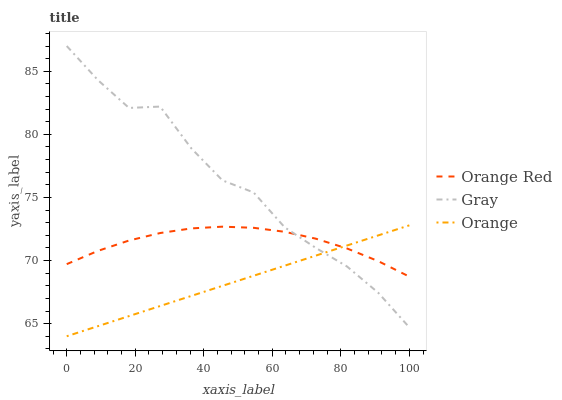Does Orange have the minimum area under the curve?
Answer yes or no. Yes. Does Gray have the maximum area under the curve?
Answer yes or no. Yes. Does Orange Red have the minimum area under the curve?
Answer yes or no. No. Does Orange Red have the maximum area under the curve?
Answer yes or no. No. Is Orange the smoothest?
Answer yes or no. Yes. Is Gray the roughest?
Answer yes or no. Yes. Is Orange Red the smoothest?
Answer yes or no. No. Is Orange Red the roughest?
Answer yes or no. No. Does Orange have the lowest value?
Answer yes or no. Yes. Does Gray have the lowest value?
Answer yes or no. No. Does Gray have the highest value?
Answer yes or no. Yes. Does Orange Red have the highest value?
Answer yes or no. No. Does Gray intersect Orange?
Answer yes or no. Yes. Is Gray less than Orange?
Answer yes or no. No. Is Gray greater than Orange?
Answer yes or no. No. 